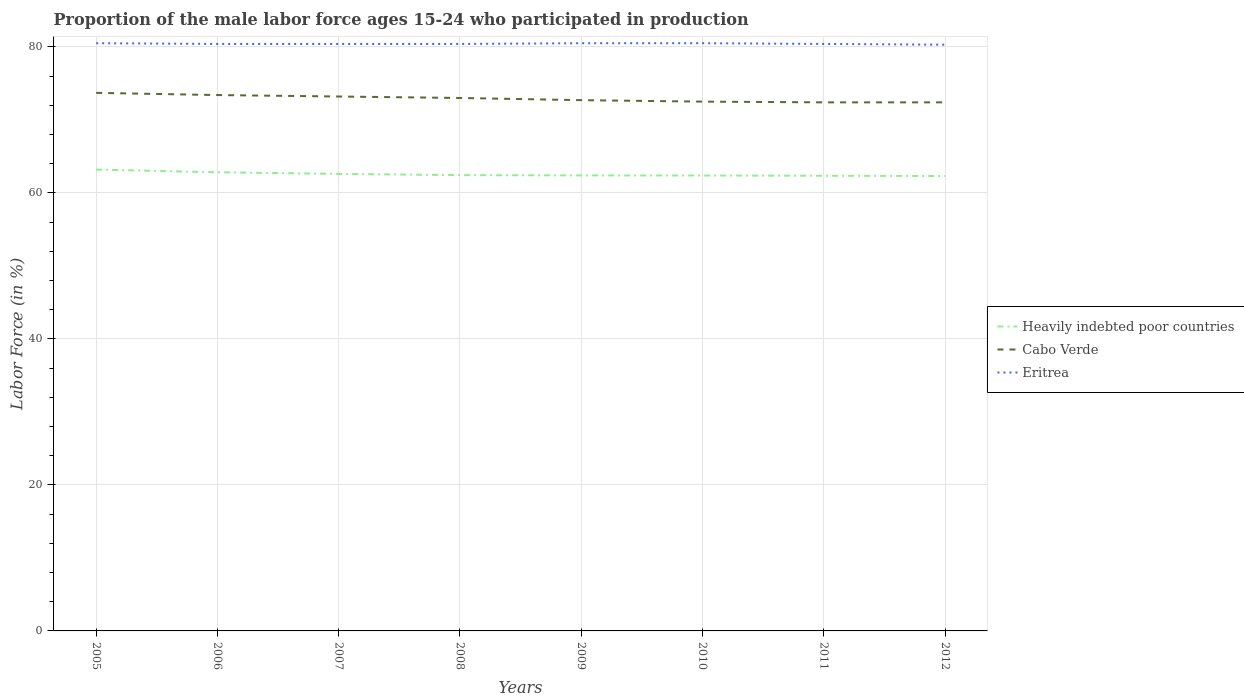Does the line corresponding to Eritrea intersect with the line corresponding to Cabo Verde?
Ensure brevity in your answer.  No. Across all years, what is the maximum proportion of the male labor force who participated in production in Heavily indebted poor countries?
Your answer should be very brief. 62.31. In which year was the proportion of the male labor force who participated in production in Heavily indebted poor countries maximum?
Provide a short and direct response. 2012. What is the total proportion of the male labor force who participated in production in Eritrea in the graph?
Give a very brief answer. -0.1. What is the difference between the highest and the second highest proportion of the male labor force who participated in production in Cabo Verde?
Provide a succinct answer. 1.3. Is the proportion of the male labor force who participated in production in Cabo Verde strictly greater than the proportion of the male labor force who participated in production in Eritrea over the years?
Provide a succinct answer. Yes. How many lines are there?
Your answer should be compact. 3. What is the difference between two consecutive major ticks on the Y-axis?
Keep it short and to the point. 20. Are the values on the major ticks of Y-axis written in scientific E-notation?
Offer a very short reply. No. Does the graph contain any zero values?
Provide a succinct answer. No. How many legend labels are there?
Ensure brevity in your answer.  3. How are the legend labels stacked?
Ensure brevity in your answer.  Vertical. What is the title of the graph?
Your answer should be compact. Proportion of the male labor force ages 15-24 who participated in production. Does "Sierra Leone" appear as one of the legend labels in the graph?
Make the answer very short. No. What is the label or title of the X-axis?
Offer a terse response. Years. What is the label or title of the Y-axis?
Your answer should be very brief. Labor Force (in %). What is the Labor Force (in %) of Heavily indebted poor countries in 2005?
Provide a short and direct response. 63.19. What is the Labor Force (in %) in Cabo Verde in 2005?
Give a very brief answer. 73.7. What is the Labor Force (in %) of Eritrea in 2005?
Give a very brief answer. 80.5. What is the Labor Force (in %) of Heavily indebted poor countries in 2006?
Provide a succinct answer. 62.83. What is the Labor Force (in %) of Cabo Verde in 2006?
Ensure brevity in your answer.  73.4. What is the Labor Force (in %) in Eritrea in 2006?
Your response must be concise. 80.4. What is the Labor Force (in %) in Heavily indebted poor countries in 2007?
Provide a succinct answer. 62.6. What is the Labor Force (in %) of Cabo Verde in 2007?
Offer a very short reply. 73.2. What is the Labor Force (in %) in Eritrea in 2007?
Give a very brief answer. 80.4. What is the Labor Force (in %) in Heavily indebted poor countries in 2008?
Keep it short and to the point. 62.43. What is the Labor Force (in %) of Cabo Verde in 2008?
Give a very brief answer. 73. What is the Labor Force (in %) in Eritrea in 2008?
Ensure brevity in your answer.  80.4. What is the Labor Force (in %) of Heavily indebted poor countries in 2009?
Offer a terse response. 62.39. What is the Labor Force (in %) of Cabo Verde in 2009?
Provide a succinct answer. 72.7. What is the Labor Force (in %) in Eritrea in 2009?
Provide a short and direct response. 80.5. What is the Labor Force (in %) in Heavily indebted poor countries in 2010?
Provide a succinct answer. 62.38. What is the Labor Force (in %) in Cabo Verde in 2010?
Your answer should be compact. 72.5. What is the Labor Force (in %) of Eritrea in 2010?
Offer a very short reply. 80.5. What is the Labor Force (in %) of Heavily indebted poor countries in 2011?
Provide a short and direct response. 62.35. What is the Labor Force (in %) of Cabo Verde in 2011?
Provide a succinct answer. 72.4. What is the Labor Force (in %) of Eritrea in 2011?
Your answer should be compact. 80.4. What is the Labor Force (in %) of Heavily indebted poor countries in 2012?
Provide a short and direct response. 62.31. What is the Labor Force (in %) of Cabo Verde in 2012?
Offer a very short reply. 72.4. What is the Labor Force (in %) of Eritrea in 2012?
Give a very brief answer. 80.3. Across all years, what is the maximum Labor Force (in %) of Heavily indebted poor countries?
Your answer should be compact. 63.19. Across all years, what is the maximum Labor Force (in %) of Cabo Verde?
Provide a short and direct response. 73.7. Across all years, what is the maximum Labor Force (in %) of Eritrea?
Give a very brief answer. 80.5. Across all years, what is the minimum Labor Force (in %) in Heavily indebted poor countries?
Ensure brevity in your answer.  62.31. Across all years, what is the minimum Labor Force (in %) of Cabo Verde?
Your answer should be compact. 72.4. Across all years, what is the minimum Labor Force (in %) of Eritrea?
Your answer should be compact. 80.3. What is the total Labor Force (in %) in Heavily indebted poor countries in the graph?
Provide a short and direct response. 500.47. What is the total Labor Force (in %) of Cabo Verde in the graph?
Offer a very short reply. 583.3. What is the total Labor Force (in %) in Eritrea in the graph?
Make the answer very short. 643.4. What is the difference between the Labor Force (in %) of Heavily indebted poor countries in 2005 and that in 2006?
Your answer should be very brief. 0.36. What is the difference between the Labor Force (in %) of Heavily indebted poor countries in 2005 and that in 2007?
Your response must be concise. 0.59. What is the difference between the Labor Force (in %) of Cabo Verde in 2005 and that in 2007?
Ensure brevity in your answer.  0.5. What is the difference between the Labor Force (in %) in Heavily indebted poor countries in 2005 and that in 2008?
Make the answer very short. 0.76. What is the difference between the Labor Force (in %) of Cabo Verde in 2005 and that in 2008?
Offer a terse response. 0.7. What is the difference between the Labor Force (in %) of Eritrea in 2005 and that in 2008?
Offer a terse response. 0.1. What is the difference between the Labor Force (in %) in Heavily indebted poor countries in 2005 and that in 2009?
Offer a very short reply. 0.8. What is the difference between the Labor Force (in %) of Eritrea in 2005 and that in 2009?
Your answer should be very brief. 0. What is the difference between the Labor Force (in %) in Heavily indebted poor countries in 2005 and that in 2010?
Your answer should be very brief. 0.81. What is the difference between the Labor Force (in %) in Cabo Verde in 2005 and that in 2010?
Your response must be concise. 1.2. What is the difference between the Labor Force (in %) of Eritrea in 2005 and that in 2010?
Offer a very short reply. 0. What is the difference between the Labor Force (in %) of Heavily indebted poor countries in 2005 and that in 2011?
Offer a terse response. 0.84. What is the difference between the Labor Force (in %) of Cabo Verde in 2005 and that in 2011?
Your response must be concise. 1.3. What is the difference between the Labor Force (in %) in Eritrea in 2005 and that in 2011?
Offer a very short reply. 0.1. What is the difference between the Labor Force (in %) of Heavily indebted poor countries in 2005 and that in 2012?
Keep it short and to the point. 0.88. What is the difference between the Labor Force (in %) in Cabo Verde in 2005 and that in 2012?
Your answer should be very brief. 1.3. What is the difference between the Labor Force (in %) of Eritrea in 2005 and that in 2012?
Provide a short and direct response. 0.2. What is the difference between the Labor Force (in %) in Heavily indebted poor countries in 2006 and that in 2007?
Keep it short and to the point. 0.23. What is the difference between the Labor Force (in %) of Cabo Verde in 2006 and that in 2007?
Offer a terse response. 0.2. What is the difference between the Labor Force (in %) of Eritrea in 2006 and that in 2007?
Your answer should be compact. 0. What is the difference between the Labor Force (in %) in Heavily indebted poor countries in 2006 and that in 2008?
Make the answer very short. 0.39. What is the difference between the Labor Force (in %) of Cabo Verde in 2006 and that in 2008?
Offer a terse response. 0.4. What is the difference between the Labor Force (in %) of Heavily indebted poor countries in 2006 and that in 2009?
Offer a terse response. 0.43. What is the difference between the Labor Force (in %) in Cabo Verde in 2006 and that in 2009?
Offer a terse response. 0.7. What is the difference between the Labor Force (in %) of Eritrea in 2006 and that in 2009?
Provide a short and direct response. -0.1. What is the difference between the Labor Force (in %) in Heavily indebted poor countries in 2006 and that in 2010?
Give a very brief answer. 0.45. What is the difference between the Labor Force (in %) of Cabo Verde in 2006 and that in 2010?
Offer a very short reply. 0.9. What is the difference between the Labor Force (in %) of Heavily indebted poor countries in 2006 and that in 2011?
Give a very brief answer. 0.48. What is the difference between the Labor Force (in %) of Heavily indebted poor countries in 2006 and that in 2012?
Your answer should be compact. 0.52. What is the difference between the Labor Force (in %) of Cabo Verde in 2006 and that in 2012?
Provide a short and direct response. 1. What is the difference between the Labor Force (in %) of Heavily indebted poor countries in 2007 and that in 2008?
Your answer should be very brief. 0.17. What is the difference between the Labor Force (in %) of Cabo Verde in 2007 and that in 2008?
Your answer should be very brief. 0.2. What is the difference between the Labor Force (in %) of Heavily indebted poor countries in 2007 and that in 2009?
Your response must be concise. 0.21. What is the difference between the Labor Force (in %) in Eritrea in 2007 and that in 2009?
Ensure brevity in your answer.  -0.1. What is the difference between the Labor Force (in %) of Heavily indebted poor countries in 2007 and that in 2010?
Give a very brief answer. 0.22. What is the difference between the Labor Force (in %) in Cabo Verde in 2007 and that in 2010?
Ensure brevity in your answer.  0.7. What is the difference between the Labor Force (in %) of Heavily indebted poor countries in 2007 and that in 2011?
Keep it short and to the point. 0.25. What is the difference between the Labor Force (in %) in Eritrea in 2007 and that in 2011?
Ensure brevity in your answer.  0. What is the difference between the Labor Force (in %) of Heavily indebted poor countries in 2007 and that in 2012?
Keep it short and to the point. 0.29. What is the difference between the Labor Force (in %) of Eritrea in 2007 and that in 2012?
Your answer should be very brief. 0.1. What is the difference between the Labor Force (in %) of Heavily indebted poor countries in 2008 and that in 2009?
Make the answer very short. 0.04. What is the difference between the Labor Force (in %) in Heavily indebted poor countries in 2008 and that in 2010?
Keep it short and to the point. 0.05. What is the difference between the Labor Force (in %) of Eritrea in 2008 and that in 2010?
Give a very brief answer. -0.1. What is the difference between the Labor Force (in %) in Heavily indebted poor countries in 2008 and that in 2011?
Your answer should be compact. 0.09. What is the difference between the Labor Force (in %) in Eritrea in 2008 and that in 2011?
Ensure brevity in your answer.  0. What is the difference between the Labor Force (in %) of Heavily indebted poor countries in 2008 and that in 2012?
Provide a succinct answer. 0.12. What is the difference between the Labor Force (in %) in Heavily indebted poor countries in 2009 and that in 2010?
Keep it short and to the point. 0.01. What is the difference between the Labor Force (in %) of Heavily indebted poor countries in 2009 and that in 2011?
Offer a very short reply. 0.05. What is the difference between the Labor Force (in %) in Cabo Verde in 2009 and that in 2011?
Ensure brevity in your answer.  0.3. What is the difference between the Labor Force (in %) of Heavily indebted poor countries in 2009 and that in 2012?
Your answer should be compact. 0.09. What is the difference between the Labor Force (in %) in Cabo Verde in 2009 and that in 2012?
Your response must be concise. 0.3. What is the difference between the Labor Force (in %) of Eritrea in 2009 and that in 2012?
Provide a short and direct response. 0.2. What is the difference between the Labor Force (in %) in Heavily indebted poor countries in 2010 and that in 2011?
Keep it short and to the point. 0.03. What is the difference between the Labor Force (in %) in Heavily indebted poor countries in 2010 and that in 2012?
Your answer should be very brief. 0.07. What is the difference between the Labor Force (in %) in Heavily indebted poor countries in 2011 and that in 2012?
Ensure brevity in your answer.  0.04. What is the difference between the Labor Force (in %) of Heavily indebted poor countries in 2005 and the Labor Force (in %) of Cabo Verde in 2006?
Provide a succinct answer. -10.21. What is the difference between the Labor Force (in %) of Heavily indebted poor countries in 2005 and the Labor Force (in %) of Eritrea in 2006?
Provide a short and direct response. -17.21. What is the difference between the Labor Force (in %) in Cabo Verde in 2005 and the Labor Force (in %) in Eritrea in 2006?
Keep it short and to the point. -6.7. What is the difference between the Labor Force (in %) in Heavily indebted poor countries in 2005 and the Labor Force (in %) in Cabo Verde in 2007?
Keep it short and to the point. -10.01. What is the difference between the Labor Force (in %) in Heavily indebted poor countries in 2005 and the Labor Force (in %) in Eritrea in 2007?
Make the answer very short. -17.21. What is the difference between the Labor Force (in %) of Heavily indebted poor countries in 2005 and the Labor Force (in %) of Cabo Verde in 2008?
Your answer should be very brief. -9.81. What is the difference between the Labor Force (in %) in Heavily indebted poor countries in 2005 and the Labor Force (in %) in Eritrea in 2008?
Keep it short and to the point. -17.21. What is the difference between the Labor Force (in %) of Cabo Verde in 2005 and the Labor Force (in %) of Eritrea in 2008?
Offer a terse response. -6.7. What is the difference between the Labor Force (in %) in Heavily indebted poor countries in 2005 and the Labor Force (in %) in Cabo Verde in 2009?
Give a very brief answer. -9.51. What is the difference between the Labor Force (in %) in Heavily indebted poor countries in 2005 and the Labor Force (in %) in Eritrea in 2009?
Your answer should be very brief. -17.31. What is the difference between the Labor Force (in %) of Heavily indebted poor countries in 2005 and the Labor Force (in %) of Cabo Verde in 2010?
Your answer should be very brief. -9.31. What is the difference between the Labor Force (in %) in Heavily indebted poor countries in 2005 and the Labor Force (in %) in Eritrea in 2010?
Give a very brief answer. -17.31. What is the difference between the Labor Force (in %) in Cabo Verde in 2005 and the Labor Force (in %) in Eritrea in 2010?
Keep it short and to the point. -6.8. What is the difference between the Labor Force (in %) in Heavily indebted poor countries in 2005 and the Labor Force (in %) in Cabo Verde in 2011?
Keep it short and to the point. -9.21. What is the difference between the Labor Force (in %) of Heavily indebted poor countries in 2005 and the Labor Force (in %) of Eritrea in 2011?
Make the answer very short. -17.21. What is the difference between the Labor Force (in %) of Cabo Verde in 2005 and the Labor Force (in %) of Eritrea in 2011?
Provide a succinct answer. -6.7. What is the difference between the Labor Force (in %) in Heavily indebted poor countries in 2005 and the Labor Force (in %) in Cabo Verde in 2012?
Provide a short and direct response. -9.21. What is the difference between the Labor Force (in %) of Heavily indebted poor countries in 2005 and the Labor Force (in %) of Eritrea in 2012?
Provide a succinct answer. -17.11. What is the difference between the Labor Force (in %) of Heavily indebted poor countries in 2006 and the Labor Force (in %) of Cabo Verde in 2007?
Make the answer very short. -10.37. What is the difference between the Labor Force (in %) in Heavily indebted poor countries in 2006 and the Labor Force (in %) in Eritrea in 2007?
Give a very brief answer. -17.57. What is the difference between the Labor Force (in %) in Heavily indebted poor countries in 2006 and the Labor Force (in %) in Cabo Verde in 2008?
Offer a very short reply. -10.17. What is the difference between the Labor Force (in %) in Heavily indebted poor countries in 2006 and the Labor Force (in %) in Eritrea in 2008?
Keep it short and to the point. -17.57. What is the difference between the Labor Force (in %) in Cabo Verde in 2006 and the Labor Force (in %) in Eritrea in 2008?
Offer a very short reply. -7. What is the difference between the Labor Force (in %) in Heavily indebted poor countries in 2006 and the Labor Force (in %) in Cabo Verde in 2009?
Keep it short and to the point. -9.87. What is the difference between the Labor Force (in %) in Heavily indebted poor countries in 2006 and the Labor Force (in %) in Eritrea in 2009?
Your response must be concise. -17.67. What is the difference between the Labor Force (in %) of Heavily indebted poor countries in 2006 and the Labor Force (in %) of Cabo Verde in 2010?
Offer a very short reply. -9.67. What is the difference between the Labor Force (in %) in Heavily indebted poor countries in 2006 and the Labor Force (in %) in Eritrea in 2010?
Your answer should be compact. -17.67. What is the difference between the Labor Force (in %) in Heavily indebted poor countries in 2006 and the Labor Force (in %) in Cabo Verde in 2011?
Offer a terse response. -9.57. What is the difference between the Labor Force (in %) of Heavily indebted poor countries in 2006 and the Labor Force (in %) of Eritrea in 2011?
Offer a terse response. -17.57. What is the difference between the Labor Force (in %) of Cabo Verde in 2006 and the Labor Force (in %) of Eritrea in 2011?
Offer a terse response. -7. What is the difference between the Labor Force (in %) of Heavily indebted poor countries in 2006 and the Labor Force (in %) of Cabo Verde in 2012?
Offer a terse response. -9.57. What is the difference between the Labor Force (in %) of Heavily indebted poor countries in 2006 and the Labor Force (in %) of Eritrea in 2012?
Offer a terse response. -17.47. What is the difference between the Labor Force (in %) of Cabo Verde in 2006 and the Labor Force (in %) of Eritrea in 2012?
Offer a terse response. -6.9. What is the difference between the Labor Force (in %) of Heavily indebted poor countries in 2007 and the Labor Force (in %) of Cabo Verde in 2008?
Ensure brevity in your answer.  -10.4. What is the difference between the Labor Force (in %) of Heavily indebted poor countries in 2007 and the Labor Force (in %) of Eritrea in 2008?
Your response must be concise. -17.8. What is the difference between the Labor Force (in %) in Heavily indebted poor countries in 2007 and the Labor Force (in %) in Cabo Verde in 2009?
Your answer should be very brief. -10.1. What is the difference between the Labor Force (in %) of Heavily indebted poor countries in 2007 and the Labor Force (in %) of Eritrea in 2009?
Ensure brevity in your answer.  -17.9. What is the difference between the Labor Force (in %) in Heavily indebted poor countries in 2007 and the Labor Force (in %) in Cabo Verde in 2010?
Keep it short and to the point. -9.9. What is the difference between the Labor Force (in %) of Heavily indebted poor countries in 2007 and the Labor Force (in %) of Eritrea in 2010?
Ensure brevity in your answer.  -17.9. What is the difference between the Labor Force (in %) in Cabo Verde in 2007 and the Labor Force (in %) in Eritrea in 2010?
Offer a very short reply. -7.3. What is the difference between the Labor Force (in %) in Heavily indebted poor countries in 2007 and the Labor Force (in %) in Cabo Verde in 2011?
Make the answer very short. -9.8. What is the difference between the Labor Force (in %) in Heavily indebted poor countries in 2007 and the Labor Force (in %) in Eritrea in 2011?
Offer a terse response. -17.8. What is the difference between the Labor Force (in %) of Heavily indebted poor countries in 2007 and the Labor Force (in %) of Cabo Verde in 2012?
Keep it short and to the point. -9.8. What is the difference between the Labor Force (in %) of Heavily indebted poor countries in 2007 and the Labor Force (in %) of Eritrea in 2012?
Your answer should be compact. -17.7. What is the difference between the Labor Force (in %) in Cabo Verde in 2007 and the Labor Force (in %) in Eritrea in 2012?
Your answer should be very brief. -7.1. What is the difference between the Labor Force (in %) in Heavily indebted poor countries in 2008 and the Labor Force (in %) in Cabo Verde in 2009?
Ensure brevity in your answer.  -10.27. What is the difference between the Labor Force (in %) in Heavily indebted poor countries in 2008 and the Labor Force (in %) in Eritrea in 2009?
Provide a short and direct response. -18.07. What is the difference between the Labor Force (in %) in Heavily indebted poor countries in 2008 and the Labor Force (in %) in Cabo Verde in 2010?
Your response must be concise. -10.07. What is the difference between the Labor Force (in %) in Heavily indebted poor countries in 2008 and the Labor Force (in %) in Eritrea in 2010?
Offer a very short reply. -18.07. What is the difference between the Labor Force (in %) in Cabo Verde in 2008 and the Labor Force (in %) in Eritrea in 2010?
Your response must be concise. -7.5. What is the difference between the Labor Force (in %) in Heavily indebted poor countries in 2008 and the Labor Force (in %) in Cabo Verde in 2011?
Keep it short and to the point. -9.97. What is the difference between the Labor Force (in %) of Heavily indebted poor countries in 2008 and the Labor Force (in %) of Eritrea in 2011?
Make the answer very short. -17.97. What is the difference between the Labor Force (in %) in Cabo Verde in 2008 and the Labor Force (in %) in Eritrea in 2011?
Provide a short and direct response. -7.4. What is the difference between the Labor Force (in %) of Heavily indebted poor countries in 2008 and the Labor Force (in %) of Cabo Verde in 2012?
Your response must be concise. -9.97. What is the difference between the Labor Force (in %) of Heavily indebted poor countries in 2008 and the Labor Force (in %) of Eritrea in 2012?
Give a very brief answer. -17.87. What is the difference between the Labor Force (in %) of Cabo Verde in 2008 and the Labor Force (in %) of Eritrea in 2012?
Offer a very short reply. -7.3. What is the difference between the Labor Force (in %) of Heavily indebted poor countries in 2009 and the Labor Force (in %) of Cabo Verde in 2010?
Offer a very short reply. -10.11. What is the difference between the Labor Force (in %) in Heavily indebted poor countries in 2009 and the Labor Force (in %) in Eritrea in 2010?
Offer a terse response. -18.11. What is the difference between the Labor Force (in %) of Heavily indebted poor countries in 2009 and the Labor Force (in %) of Cabo Verde in 2011?
Keep it short and to the point. -10.01. What is the difference between the Labor Force (in %) of Heavily indebted poor countries in 2009 and the Labor Force (in %) of Eritrea in 2011?
Make the answer very short. -18.01. What is the difference between the Labor Force (in %) of Cabo Verde in 2009 and the Labor Force (in %) of Eritrea in 2011?
Make the answer very short. -7.7. What is the difference between the Labor Force (in %) of Heavily indebted poor countries in 2009 and the Labor Force (in %) of Cabo Verde in 2012?
Keep it short and to the point. -10.01. What is the difference between the Labor Force (in %) of Heavily indebted poor countries in 2009 and the Labor Force (in %) of Eritrea in 2012?
Give a very brief answer. -17.91. What is the difference between the Labor Force (in %) in Heavily indebted poor countries in 2010 and the Labor Force (in %) in Cabo Verde in 2011?
Give a very brief answer. -10.02. What is the difference between the Labor Force (in %) of Heavily indebted poor countries in 2010 and the Labor Force (in %) of Eritrea in 2011?
Give a very brief answer. -18.02. What is the difference between the Labor Force (in %) of Heavily indebted poor countries in 2010 and the Labor Force (in %) of Cabo Verde in 2012?
Make the answer very short. -10.02. What is the difference between the Labor Force (in %) in Heavily indebted poor countries in 2010 and the Labor Force (in %) in Eritrea in 2012?
Offer a very short reply. -17.92. What is the difference between the Labor Force (in %) in Heavily indebted poor countries in 2011 and the Labor Force (in %) in Cabo Verde in 2012?
Make the answer very short. -10.05. What is the difference between the Labor Force (in %) of Heavily indebted poor countries in 2011 and the Labor Force (in %) of Eritrea in 2012?
Your answer should be very brief. -17.95. What is the difference between the Labor Force (in %) of Cabo Verde in 2011 and the Labor Force (in %) of Eritrea in 2012?
Keep it short and to the point. -7.9. What is the average Labor Force (in %) in Heavily indebted poor countries per year?
Keep it short and to the point. 62.56. What is the average Labor Force (in %) of Cabo Verde per year?
Give a very brief answer. 72.91. What is the average Labor Force (in %) in Eritrea per year?
Make the answer very short. 80.42. In the year 2005, what is the difference between the Labor Force (in %) in Heavily indebted poor countries and Labor Force (in %) in Cabo Verde?
Your answer should be very brief. -10.51. In the year 2005, what is the difference between the Labor Force (in %) in Heavily indebted poor countries and Labor Force (in %) in Eritrea?
Offer a very short reply. -17.31. In the year 2006, what is the difference between the Labor Force (in %) in Heavily indebted poor countries and Labor Force (in %) in Cabo Verde?
Provide a short and direct response. -10.57. In the year 2006, what is the difference between the Labor Force (in %) of Heavily indebted poor countries and Labor Force (in %) of Eritrea?
Offer a very short reply. -17.57. In the year 2006, what is the difference between the Labor Force (in %) of Cabo Verde and Labor Force (in %) of Eritrea?
Give a very brief answer. -7. In the year 2007, what is the difference between the Labor Force (in %) of Heavily indebted poor countries and Labor Force (in %) of Cabo Verde?
Your answer should be compact. -10.6. In the year 2007, what is the difference between the Labor Force (in %) of Heavily indebted poor countries and Labor Force (in %) of Eritrea?
Offer a terse response. -17.8. In the year 2008, what is the difference between the Labor Force (in %) in Heavily indebted poor countries and Labor Force (in %) in Cabo Verde?
Keep it short and to the point. -10.57. In the year 2008, what is the difference between the Labor Force (in %) of Heavily indebted poor countries and Labor Force (in %) of Eritrea?
Your answer should be very brief. -17.97. In the year 2009, what is the difference between the Labor Force (in %) of Heavily indebted poor countries and Labor Force (in %) of Cabo Verde?
Keep it short and to the point. -10.31. In the year 2009, what is the difference between the Labor Force (in %) of Heavily indebted poor countries and Labor Force (in %) of Eritrea?
Provide a short and direct response. -18.11. In the year 2010, what is the difference between the Labor Force (in %) of Heavily indebted poor countries and Labor Force (in %) of Cabo Verde?
Offer a terse response. -10.12. In the year 2010, what is the difference between the Labor Force (in %) of Heavily indebted poor countries and Labor Force (in %) of Eritrea?
Give a very brief answer. -18.12. In the year 2011, what is the difference between the Labor Force (in %) in Heavily indebted poor countries and Labor Force (in %) in Cabo Verde?
Provide a short and direct response. -10.05. In the year 2011, what is the difference between the Labor Force (in %) in Heavily indebted poor countries and Labor Force (in %) in Eritrea?
Your answer should be compact. -18.05. In the year 2011, what is the difference between the Labor Force (in %) of Cabo Verde and Labor Force (in %) of Eritrea?
Your answer should be very brief. -8. In the year 2012, what is the difference between the Labor Force (in %) of Heavily indebted poor countries and Labor Force (in %) of Cabo Verde?
Your response must be concise. -10.09. In the year 2012, what is the difference between the Labor Force (in %) of Heavily indebted poor countries and Labor Force (in %) of Eritrea?
Offer a very short reply. -17.99. In the year 2012, what is the difference between the Labor Force (in %) of Cabo Verde and Labor Force (in %) of Eritrea?
Keep it short and to the point. -7.9. What is the ratio of the Labor Force (in %) of Cabo Verde in 2005 to that in 2006?
Provide a short and direct response. 1. What is the ratio of the Labor Force (in %) in Eritrea in 2005 to that in 2006?
Your response must be concise. 1. What is the ratio of the Labor Force (in %) in Heavily indebted poor countries in 2005 to that in 2007?
Make the answer very short. 1.01. What is the ratio of the Labor Force (in %) of Cabo Verde in 2005 to that in 2007?
Your response must be concise. 1.01. What is the ratio of the Labor Force (in %) in Heavily indebted poor countries in 2005 to that in 2008?
Give a very brief answer. 1.01. What is the ratio of the Labor Force (in %) in Cabo Verde in 2005 to that in 2008?
Keep it short and to the point. 1.01. What is the ratio of the Labor Force (in %) of Eritrea in 2005 to that in 2008?
Offer a very short reply. 1. What is the ratio of the Labor Force (in %) in Heavily indebted poor countries in 2005 to that in 2009?
Keep it short and to the point. 1.01. What is the ratio of the Labor Force (in %) in Cabo Verde in 2005 to that in 2009?
Your answer should be compact. 1.01. What is the ratio of the Labor Force (in %) of Eritrea in 2005 to that in 2009?
Your answer should be very brief. 1. What is the ratio of the Labor Force (in %) of Heavily indebted poor countries in 2005 to that in 2010?
Ensure brevity in your answer.  1.01. What is the ratio of the Labor Force (in %) in Cabo Verde in 2005 to that in 2010?
Your answer should be compact. 1.02. What is the ratio of the Labor Force (in %) of Heavily indebted poor countries in 2005 to that in 2011?
Give a very brief answer. 1.01. What is the ratio of the Labor Force (in %) of Cabo Verde in 2005 to that in 2011?
Your response must be concise. 1.02. What is the ratio of the Labor Force (in %) of Heavily indebted poor countries in 2005 to that in 2012?
Make the answer very short. 1.01. What is the ratio of the Labor Force (in %) of Heavily indebted poor countries in 2006 to that in 2007?
Your answer should be compact. 1. What is the ratio of the Labor Force (in %) in Cabo Verde in 2006 to that in 2007?
Provide a short and direct response. 1. What is the ratio of the Labor Force (in %) in Cabo Verde in 2006 to that in 2008?
Keep it short and to the point. 1.01. What is the ratio of the Labor Force (in %) in Eritrea in 2006 to that in 2008?
Offer a very short reply. 1. What is the ratio of the Labor Force (in %) in Heavily indebted poor countries in 2006 to that in 2009?
Offer a very short reply. 1.01. What is the ratio of the Labor Force (in %) in Cabo Verde in 2006 to that in 2009?
Ensure brevity in your answer.  1.01. What is the ratio of the Labor Force (in %) in Eritrea in 2006 to that in 2009?
Your response must be concise. 1. What is the ratio of the Labor Force (in %) of Heavily indebted poor countries in 2006 to that in 2010?
Make the answer very short. 1.01. What is the ratio of the Labor Force (in %) of Cabo Verde in 2006 to that in 2010?
Your answer should be compact. 1.01. What is the ratio of the Labor Force (in %) in Heavily indebted poor countries in 2006 to that in 2011?
Make the answer very short. 1.01. What is the ratio of the Labor Force (in %) of Cabo Verde in 2006 to that in 2011?
Make the answer very short. 1.01. What is the ratio of the Labor Force (in %) of Eritrea in 2006 to that in 2011?
Keep it short and to the point. 1. What is the ratio of the Labor Force (in %) in Heavily indebted poor countries in 2006 to that in 2012?
Provide a short and direct response. 1.01. What is the ratio of the Labor Force (in %) in Cabo Verde in 2006 to that in 2012?
Keep it short and to the point. 1.01. What is the ratio of the Labor Force (in %) in Heavily indebted poor countries in 2007 to that in 2008?
Provide a short and direct response. 1. What is the ratio of the Labor Force (in %) of Cabo Verde in 2007 to that in 2009?
Keep it short and to the point. 1.01. What is the ratio of the Labor Force (in %) in Eritrea in 2007 to that in 2009?
Ensure brevity in your answer.  1. What is the ratio of the Labor Force (in %) of Cabo Verde in 2007 to that in 2010?
Your answer should be very brief. 1.01. What is the ratio of the Labor Force (in %) of Eritrea in 2007 to that in 2010?
Offer a very short reply. 1. What is the ratio of the Labor Force (in %) of Heavily indebted poor countries in 2007 to that in 2011?
Provide a short and direct response. 1. What is the ratio of the Labor Force (in %) in Cabo Verde in 2007 to that in 2011?
Give a very brief answer. 1.01. What is the ratio of the Labor Force (in %) of Heavily indebted poor countries in 2008 to that in 2009?
Your response must be concise. 1. What is the ratio of the Labor Force (in %) of Heavily indebted poor countries in 2008 to that in 2010?
Your response must be concise. 1. What is the ratio of the Labor Force (in %) of Heavily indebted poor countries in 2008 to that in 2011?
Give a very brief answer. 1. What is the ratio of the Labor Force (in %) in Cabo Verde in 2008 to that in 2011?
Provide a succinct answer. 1.01. What is the ratio of the Labor Force (in %) in Eritrea in 2008 to that in 2011?
Ensure brevity in your answer.  1. What is the ratio of the Labor Force (in %) in Heavily indebted poor countries in 2008 to that in 2012?
Give a very brief answer. 1. What is the ratio of the Labor Force (in %) of Cabo Verde in 2008 to that in 2012?
Make the answer very short. 1.01. What is the ratio of the Labor Force (in %) of Eritrea in 2008 to that in 2012?
Offer a terse response. 1. What is the ratio of the Labor Force (in %) in Heavily indebted poor countries in 2009 to that in 2010?
Offer a terse response. 1. What is the ratio of the Labor Force (in %) in Cabo Verde in 2009 to that in 2011?
Give a very brief answer. 1. What is the ratio of the Labor Force (in %) in Eritrea in 2009 to that in 2011?
Provide a short and direct response. 1. What is the ratio of the Labor Force (in %) of Heavily indebted poor countries in 2010 to that in 2011?
Your answer should be compact. 1. What is the ratio of the Labor Force (in %) in Cabo Verde in 2010 to that in 2011?
Your answer should be very brief. 1. What is the ratio of the Labor Force (in %) of Cabo Verde in 2010 to that in 2012?
Make the answer very short. 1. What is the ratio of the Labor Force (in %) in Cabo Verde in 2011 to that in 2012?
Provide a short and direct response. 1. What is the difference between the highest and the second highest Labor Force (in %) in Heavily indebted poor countries?
Give a very brief answer. 0.36. What is the difference between the highest and the second highest Labor Force (in %) of Cabo Verde?
Your response must be concise. 0.3. What is the difference between the highest and the second highest Labor Force (in %) in Eritrea?
Make the answer very short. 0. What is the difference between the highest and the lowest Labor Force (in %) in Heavily indebted poor countries?
Your answer should be compact. 0.88. 